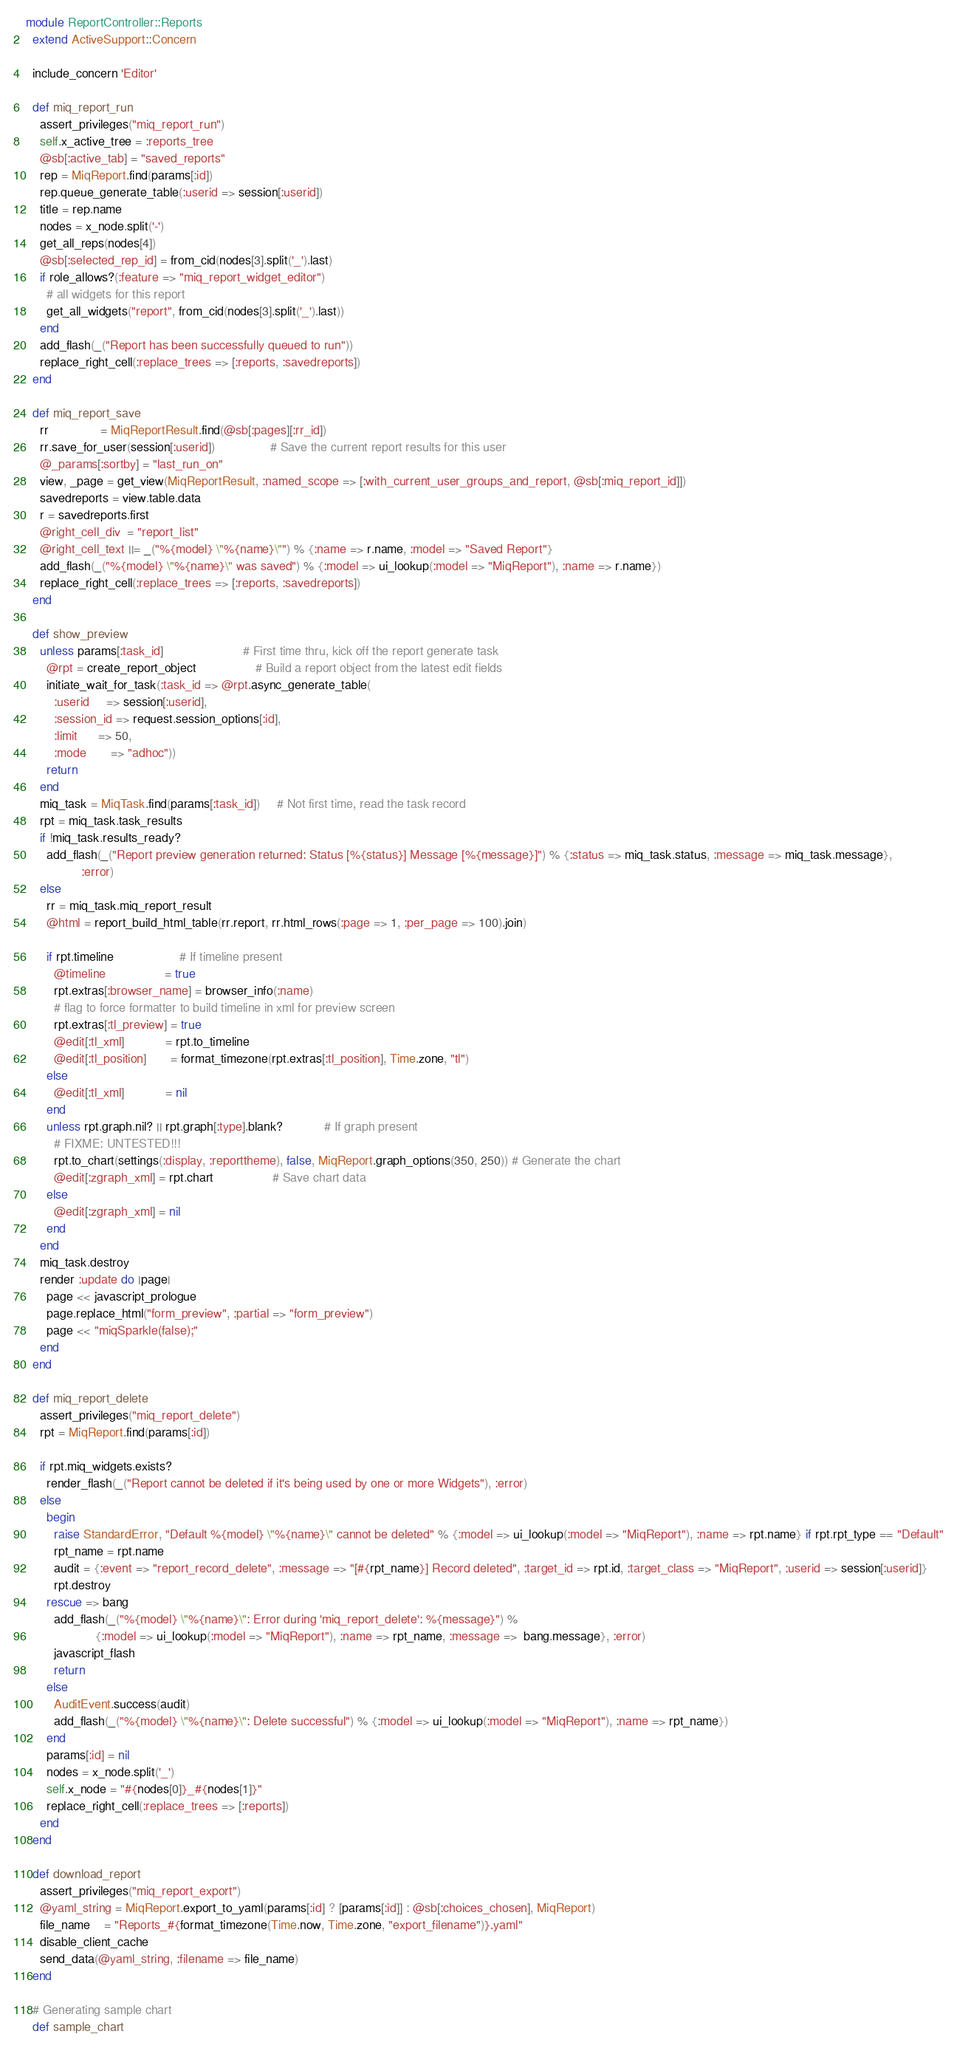Convert code to text. <code><loc_0><loc_0><loc_500><loc_500><_Ruby_>module ReportController::Reports
  extend ActiveSupport::Concern

  include_concern 'Editor'

  def miq_report_run
    assert_privileges("miq_report_run")
    self.x_active_tree = :reports_tree
    @sb[:active_tab] = "saved_reports"
    rep = MiqReport.find(params[:id])
    rep.queue_generate_table(:userid => session[:userid])
    title = rep.name
    nodes = x_node.split('-')
    get_all_reps(nodes[4])
    @sb[:selected_rep_id] = from_cid(nodes[3].split('_').last)
    if role_allows?(:feature => "miq_report_widget_editor")
      # all widgets for this report
      get_all_widgets("report", from_cid(nodes[3].split('_').last))
    end
    add_flash(_("Report has been successfully queued to run"))
    replace_right_cell(:replace_trees => [:reports, :savedreports])
  end

  def miq_report_save
    rr               = MiqReportResult.find(@sb[:pages][:rr_id])
    rr.save_for_user(session[:userid])                # Save the current report results for this user
    @_params[:sortby] = "last_run_on"
    view, _page = get_view(MiqReportResult, :named_scope => [:with_current_user_groups_and_report, @sb[:miq_report_id]])
    savedreports = view.table.data
    r = savedreports.first
    @right_cell_div  = "report_list"
    @right_cell_text ||= _("%{model} \"%{name}\"") % {:name => r.name, :model => "Saved Report"}
    add_flash(_("%{model} \"%{name}\" was saved") % {:model => ui_lookup(:model => "MiqReport"), :name => r.name})
    replace_right_cell(:replace_trees => [:reports, :savedreports])
  end

  def show_preview
    unless params[:task_id]                       # First time thru, kick off the report generate task
      @rpt = create_report_object                 # Build a report object from the latest edit fields
      initiate_wait_for_task(:task_id => @rpt.async_generate_table(
        :userid     => session[:userid],
        :session_id => request.session_options[:id],
        :limit      => 50,
        :mode       => "adhoc"))
      return
    end
    miq_task = MiqTask.find(params[:task_id])     # Not first time, read the task record
    rpt = miq_task.task_results
    if !miq_task.results_ready?
      add_flash(_("Report preview generation returned: Status [%{status}] Message [%{message}]") % {:status => miq_task.status, :message => miq_task.message},
                :error)
    else
      rr = miq_task.miq_report_result
      @html = report_build_html_table(rr.report, rr.html_rows(:page => 1, :per_page => 100).join)

      if rpt.timeline                   # If timeline present
        @timeline                 = true
        rpt.extras[:browser_name] = browser_info(:name)
        # flag to force formatter to build timeline in xml for preview screen
        rpt.extras[:tl_preview] = true
        @edit[:tl_xml]            = rpt.to_timeline
        @edit[:tl_position]       = format_timezone(rpt.extras[:tl_position], Time.zone, "tl")
      else
        @edit[:tl_xml]            = nil
      end
      unless rpt.graph.nil? || rpt.graph[:type].blank?            # If graph present
        # FIXME: UNTESTED!!!
        rpt.to_chart(settings(:display, :reporttheme), false, MiqReport.graph_options(350, 250)) # Generate the chart
        @edit[:zgraph_xml] = rpt.chart                 # Save chart data
      else
        @edit[:zgraph_xml] = nil
      end
    end
    miq_task.destroy
    render :update do |page|
      page << javascript_prologue
      page.replace_html("form_preview", :partial => "form_preview")
      page << "miqSparkle(false);"
    end
  end

  def miq_report_delete
    assert_privileges("miq_report_delete")
    rpt = MiqReport.find(params[:id])

    if rpt.miq_widgets.exists?
      render_flash(_("Report cannot be deleted if it's being used by one or more Widgets"), :error)
    else
      begin
        raise StandardError, "Default %{model} \"%{name}\" cannot be deleted" % {:model => ui_lookup(:model => "MiqReport"), :name => rpt.name} if rpt.rpt_type == "Default"
        rpt_name = rpt.name
        audit = {:event => "report_record_delete", :message => "[#{rpt_name}] Record deleted", :target_id => rpt.id, :target_class => "MiqReport", :userid => session[:userid]}
        rpt.destroy
      rescue => bang
        add_flash(_("%{model} \"%{name}\": Error during 'miq_report_delete': %{message}") %
                    {:model => ui_lookup(:model => "MiqReport"), :name => rpt_name, :message =>  bang.message}, :error)
        javascript_flash
        return
      else
        AuditEvent.success(audit)
        add_flash(_("%{model} \"%{name}\": Delete successful") % {:model => ui_lookup(:model => "MiqReport"), :name => rpt_name})
      end
      params[:id] = nil
      nodes = x_node.split('_')
      self.x_node = "#{nodes[0]}_#{nodes[1]}"
      replace_right_cell(:replace_trees => [:reports])
    end
  end

  def download_report
    assert_privileges("miq_report_export")
    @yaml_string = MiqReport.export_to_yaml(params[:id] ? [params[:id]] : @sb[:choices_chosen], MiqReport)
    file_name    = "Reports_#{format_timezone(Time.now, Time.zone, "export_filename")}.yaml"
    disable_client_cache
    send_data(@yaml_string, :filename => file_name)
  end

  # Generating sample chart
  def sample_chart</code> 